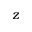<formula> <loc_0><loc_0><loc_500><loc_500>z</formula> 